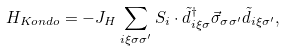<formula> <loc_0><loc_0><loc_500><loc_500>H _ { K o n d o } = - J _ { H } \sum _ { { i } \xi \sigma \sigma ^ { \prime } } { S } _ { i } \cdot \tilde { d } ^ { \dagger } _ { { i } \xi \sigma } \vec { \sigma } _ { \sigma \sigma ^ { \prime } } \tilde { d } _ { { i } \xi \sigma ^ { \prime } } ,</formula> 